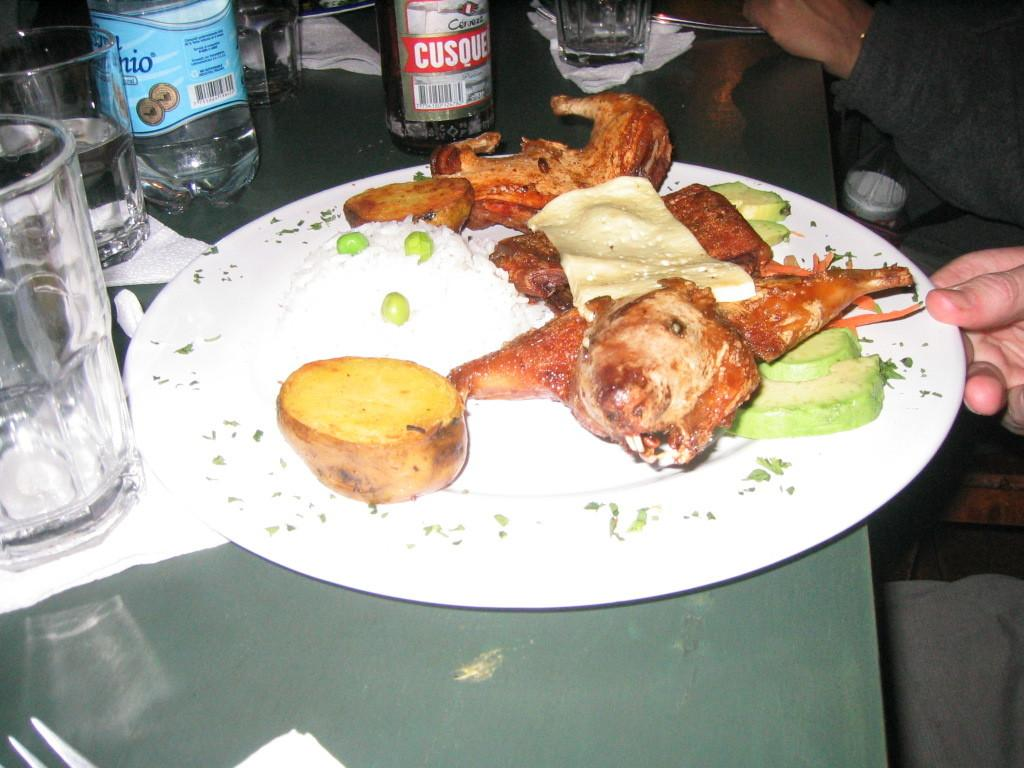What is on the plate that is visible in the image? There is a plate with food in the image. What else can be seen in the image besides the plate? There are glasses and bottles visible in the image. Who is holding the plate in the image? One person is holding the plate in the image. How many women are present in the image? There is no information about women in the image, as the facts only mention a plate with food, glasses, bottles, and a person holding the plate. 